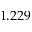Convert formula to latex. <formula><loc_0><loc_0><loc_500><loc_500>1 . 2 2 9</formula> 